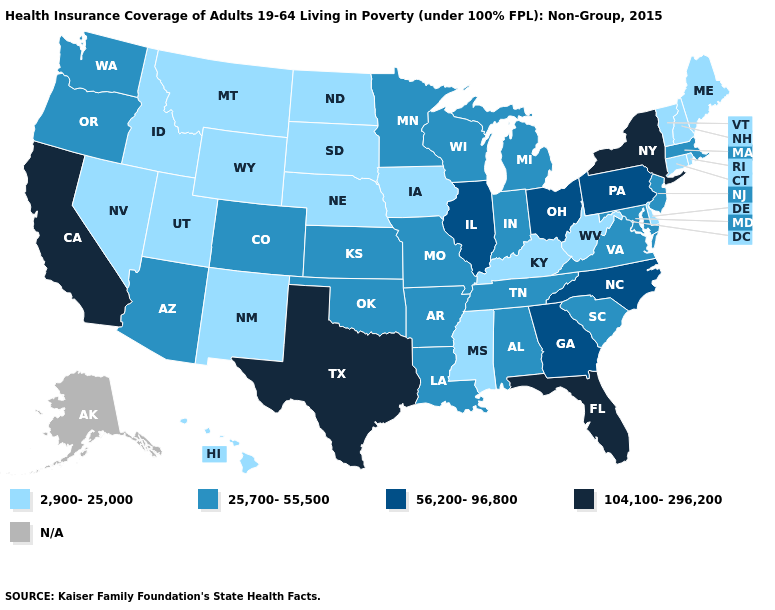What is the lowest value in the USA?
Be succinct. 2,900-25,000. What is the value of Indiana?
Be succinct. 25,700-55,500. Among the states that border Oregon , which have the lowest value?
Write a very short answer. Idaho, Nevada. What is the value of North Dakota?
Short answer required. 2,900-25,000. Among the states that border Texas , which have the highest value?
Write a very short answer. Arkansas, Louisiana, Oklahoma. What is the lowest value in the South?
Quick response, please. 2,900-25,000. Does the map have missing data?
Keep it brief. Yes. Does Arizona have the highest value in the USA?
Give a very brief answer. No. Name the states that have a value in the range 104,100-296,200?
Short answer required. California, Florida, New York, Texas. How many symbols are there in the legend?
Be succinct. 5. What is the highest value in states that border Alabama?
Keep it brief. 104,100-296,200. Does the map have missing data?
Give a very brief answer. Yes. Which states have the lowest value in the USA?
Quick response, please. Connecticut, Delaware, Hawaii, Idaho, Iowa, Kentucky, Maine, Mississippi, Montana, Nebraska, Nevada, New Hampshire, New Mexico, North Dakota, Rhode Island, South Dakota, Utah, Vermont, West Virginia, Wyoming. 